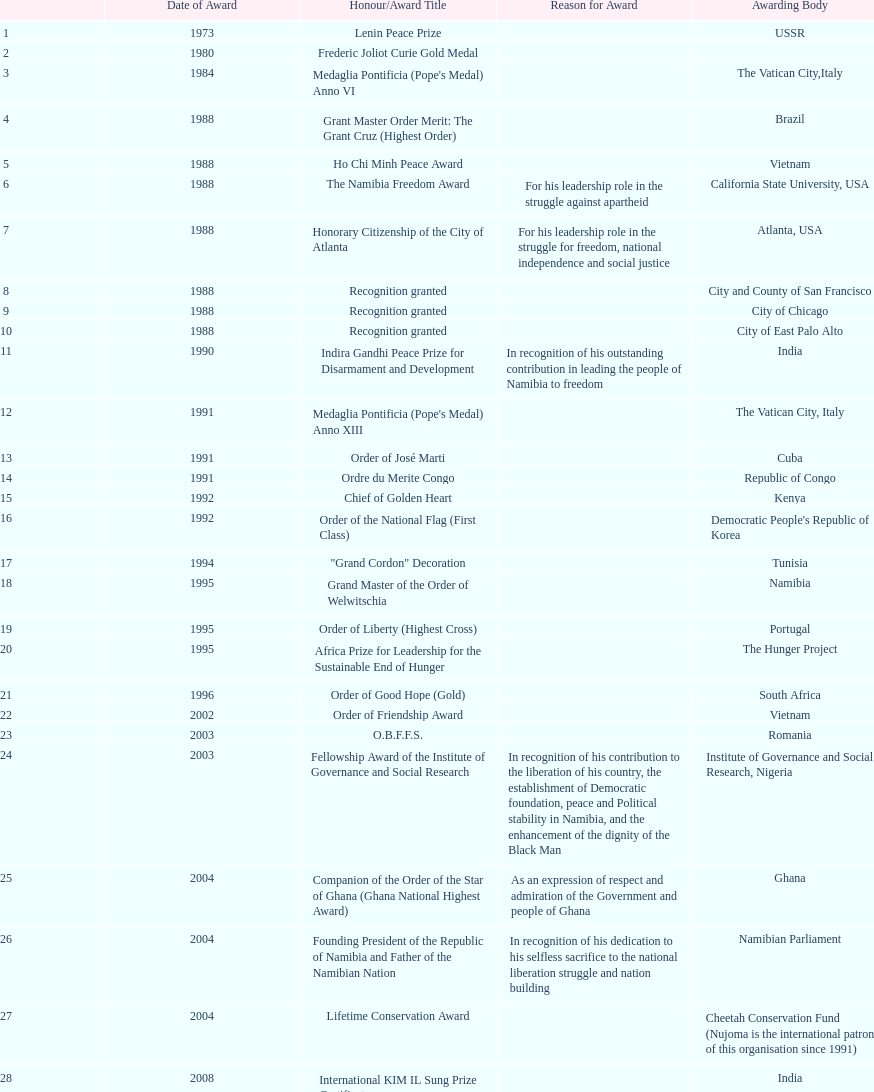What was the name of the recognition/award given subsequent to the international kim il sung prize certificate? Sir Seretse Khama SADC Meda. 